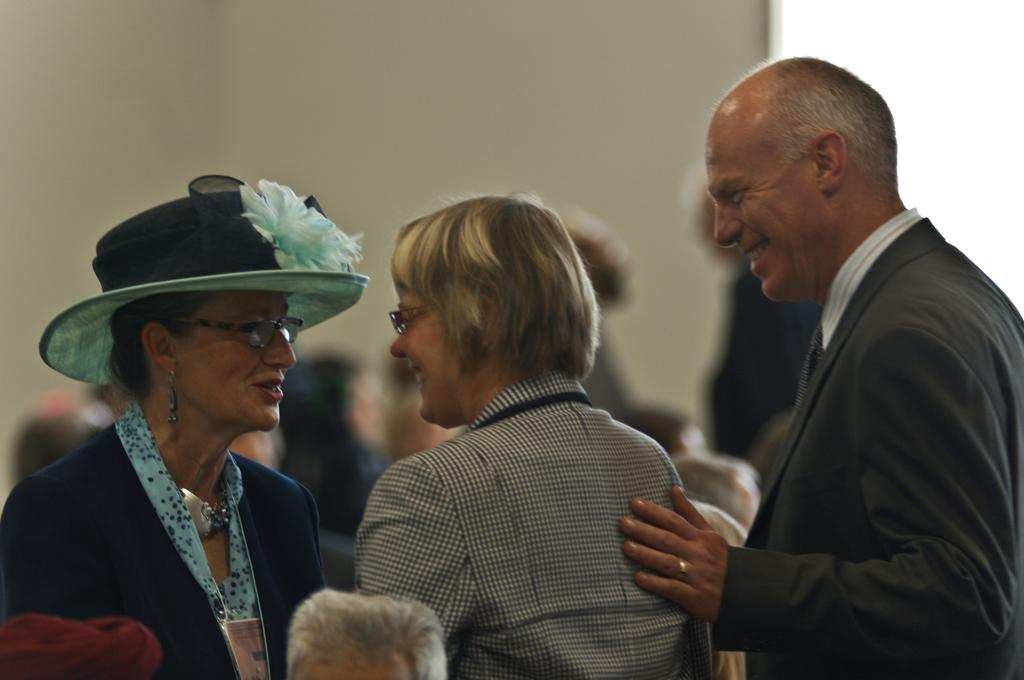How many people are in the image? There are three people in the image. What is the facial expression of the people in the image? The people are smiling. Can you describe the background of the image? The background of the image is blurry. Are there any other people visible in the image besides the main three? Yes, there are people visible in the background. Where are the people's heads located in the image? There are people's heads in the bottom left side of the image. What type of advice can be seen being given in the image? There is no advice being given in the image; it features three people smiling. What kind of brush is being used by the person in the image? There is no brush present in the image. 